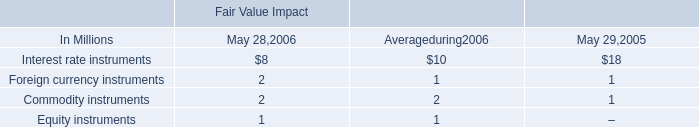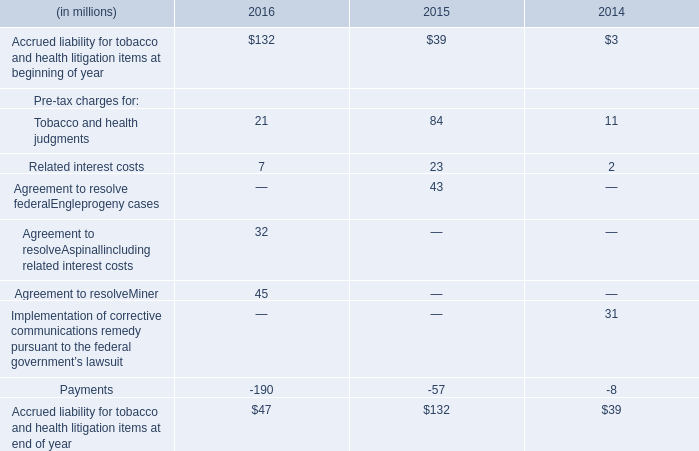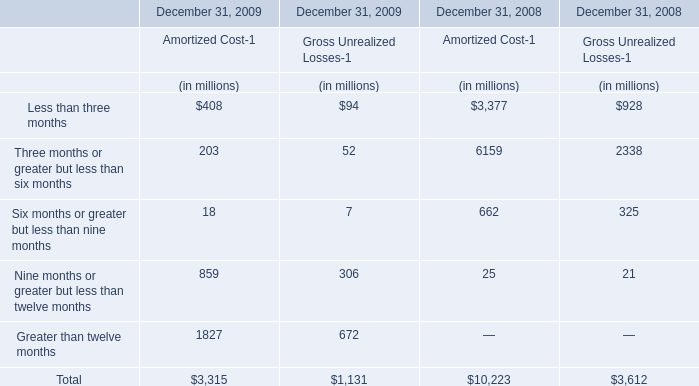In which section is Less than three months smaller than Three months or greater but less than six months in 2008? 
Answer: Amortized Cost-1 and Gross Unrealized Losses-1. 